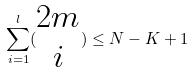<formula> <loc_0><loc_0><loc_500><loc_500>\sum _ { i = 1 } ^ { l } ( \begin{matrix} 2 m \\ i \end{matrix} ) \leq N - K + 1</formula> 